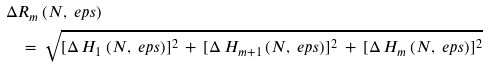<formula> <loc_0><loc_0><loc_500><loc_500>\Delta & R _ { m } \, ( N , \ e p s ) \\ & \, = \, \sqrt { [ \Delta \, H _ { 1 } \, ( N , \ e p s ) ] ^ { 2 } \, + \, [ \Delta \, H _ { m + 1 } \, ( N , \ e p s ) ] ^ { 2 } \, + \, [ \Delta \, H _ { m } \, ( N , \ e p s ) ] ^ { 2 } }</formula> 